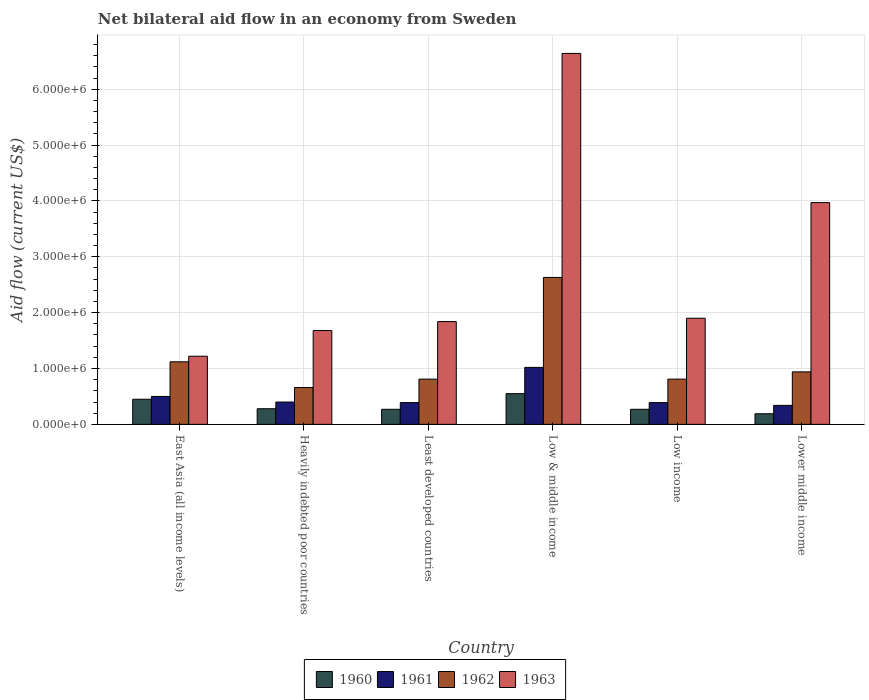How many different coloured bars are there?
Ensure brevity in your answer.  4. How many groups of bars are there?
Your response must be concise. 6. Are the number of bars per tick equal to the number of legend labels?
Make the answer very short. Yes. How many bars are there on the 6th tick from the left?
Keep it short and to the point. 4. How many bars are there on the 6th tick from the right?
Your answer should be very brief. 4. What is the label of the 6th group of bars from the left?
Your answer should be compact. Lower middle income. Across all countries, what is the maximum net bilateral aid flow in 1961?
Make the answer very short. 1.02e+06. In which country was the net bilateral aid flow in 1960 maximum?
Provide a succinct answer. Low & middle income. In which country was the net bilateral aid flow in 1962 minimum?
Offer a very short reply. Heavily indebted poor countries. What is the total net bilateral aid flow in 1960 in the graph?
Your response must be concise. 2.01e+06. What is the difference between the net bilateral aid flow in 1960 in Low & middle income and the net bilateral aid flow in 1963 in Lower middle income?
Your answer should be compact. -3.42e+06. What is the average net bilateral aid flow in 1960 per country?
Offer a very short reply. 3.35e+05. What is the difference between the net bilateral aid flow of/in 1962 and net bilateral aid flow of/in 1960 in Lower middle income?
Provide a short and direct response. 7.50e+05. What is the ratio of the net bilateral aid flow in 1960 in Least developed countries to that in Lower middle income?
Provide a short and direct response. 1.42. Is the net bilateral aid flow in 1962 in Low & middle income less than that in Low income?
Your answer should be compact. No. What is the difference between the highest and the second highest net bilateral aid flow in 1962?
Make the answer very short. 1.51e+06. What is the difference between the highest and the lowest net bilateral aid flow in 1961?
Make the answer very short. 6.80e+05. Is the sum of the net bilateral aid flow in 1962 in Least developed countries and Lower middle income greater than the maximum net bilateral aid flow in 1963 across all countries?
Provide a succinct answer. No. Is it the case that in every country, the sum of the net bilateral aid flow in 1962 and net bilateral aid flow in 1961 is greater than the net bilateral aid flow in 1960?
Keep it short and to the point. Yes. How many bars are there?
Offer a terse response. 24. How many countries are there in the graph?
Keep it short and to the point. 6. What is the difference between two consecutive major ticks on the Y-axis?
Make the answer very short. 1.00e+06. Does the graph contain any zero values?
Your answer should be very brief. No. Where does the legend appear in the graph?
Make the answer very short. Bottom center. How are the legend labels stacked?
Your response must be concise. Horizontal. What is the title of the graph?
Offer a very short reply. Net bilateral aid flow in an economy from Sweden. Does "2009" appear as one of the legend labels in the graph?
Provide a succinct answer. No. What is the Aid flow (current US$) in 1962 in East Asia (all income levels)?
Provide a succinct answer. 1.12e+06. What is the Aid flow (current US$) in 1963 in East Asia (all income levels)?
Provide a succinct answer. 1.22e+06. What is the Aid flow (current US$) in 1960 in Heavily indebted poor countries?
Your answer should be very brief. 2.80e+05. What is the Aid flow (current US$) of 1961 in Heavily indebted poor countries?
Your answer should be very brief. 4.00e+05. What is the Aid flow (current US$) of 1962 in Heavily indebted poor countries?
Make the answer very short. 6.60e+05. What is the Aid flow (current US$) of 1963 in Heavily indebted poor countries?
Your answer should be compact. 1.68e+06. What is the Aid flow (current US$) in 1962 in Least developed countries?
Your response must be concise. 8.10e+05. What is the Aid flow (current US$) in 1963 in Least developed countries?
Your response must be concise. 1.84e+06. What is the Aid flow (current US$) of 1960 in Low & middle income?
Offer a terse response. 5.50e+05. What is the Aid flow (current US$) in 1961 in Low & middle income?
Your answer should be very brief. 1.02e+06. What is the Aid flow (current US$) of 1962 in Low & middle income?
Your response must be concise. 2.63e+06. What is the Aid flow (current US$) of 1963 in Low & middle income?
Your answer should be very brief. 6.64e+06. What is the Aid flow (current US$) of 1960 in Low income?
Your response must be concise. 2.70e+05. What is the Aid flow (current US$) of 1961 in Low income?
Give a very brief answer. 3.90e+05. What is the Aid flow (current US$) in 1962 in Low income?
Make the answer very short. 8.10e+05. What is the Aid flow (current US$) in 1963 in Low income?
Provide a succinct answer. 1.90e+06. What is the Aid flow (current US$) of 1960 in Lower middle income?
Give a very brief answer. 1.90e+05. What is the Aid flow (current US$) of 1961 in Lower middle income?
Offer a very short reply. 3.40e+05. What is the Aid flow (current US$) of 1962 in Lower middle income?
Offer a very short reply. 9.40e+05. What is the Aid flow (current US$) of 1963 in Lower middle income?
Ensure brevity in your answer.  3.97e+06. Across all countries, what is the maximum Aid flow (current US$) in 1960?
Provide a short and direct response. 5.50e+05. Across all countries, what is the maximum Aid flow (current US$) of 1961?
Offer a terse response. 1.02e+06. Across all countries, what is the maximum Aid flow (current US$) in 1962?
Make the answer very short. 2.63e+06. Across all countries, what is the maximum Aid flow (current US$) of 1963?
Offer a very short reply. 6.64e+06. Across all countries, what is the minimum Aid flow (current US$) of 1962?
Offer a terse response. 6.60e+05. Across all countries, what is the minimum Aid flow (current US$) in 1963?
Offer a very short reply. 1.22e+06. What is the total Aid flow (current US$) in 1960 in the graph?
Keep it short and to the point. 2.01e+06. What is the total Aid flow (current US$) of 1961 in the graph?
Your answer should be very brief. 3.04e+06. What is the total Aid flow (current US$) in 1962 in the graph?
Your response must be concise. 6.97e+06. What is the total Aid flow (current US$) of 1963 in the graph?
Offer a very short reply. 1.72e+07. What is the difference between the Aid flow (current US$) of 1963 in East Asia (all income levels) and that in Heavily indebted poor countries?
Ensure brevity in your answer.  -4.60e+05. What is the difference between the Aid flow (current US$) of 1963 in East Asia (all income levels) and that in Least developed countries?
Provide a short and direct response. -6.20e+05. What is the difference between the Aid flow (current US$) of 1961 in East Asia (all income levels) and that in Low & middle income?
Offer a terse response. -5.20e+05. What is the difference between the Aid flow (current US$) in 1962 in East Asia (all income levels) and that in Low & middle income?
Your answer should be compact. -1.51e+06. What is the difference between the Aid flow (current US$) in 1963 in East Asia (all income levels) and that in Low & middle income?
Make the answer very short. -5.42e+06. What is the difference between the Aid flow (current US$) in 1960 in East Asia (all income levels) and that in Low income?
Make the answer very short. 1.80e+05. What is the difference between the Aid flow (current US$) in 1961 in East Asia (all income levels) and that in Low income?
Provide a succinct answer. 1.10e+05. What is the difference between the Aid flow (current US$) in 1962 in East Asia (all income levels) and that in Low income?
Your response must be concise. 3.10e+05. What is the difference between the Aid flow (current US$) of 1963 in East Asia (all income levels) and that in Low income?
Provide a succinct answer. -6.80e+05. What is the difference between the Aid flow (current US$) of 1960 in East Asia (all income levels) and that in Lower middle income?
Make the answer very short. 2.60e+05. What is the difference between the Aid flow (current US$) of 1961 in East Asia (all income levels) and that in Lower middle income?
Make the answer very short. 1.60e+05. What is the difference between the Aid flow (current US$) of 1963 in East Asia (all income levels) and that in Lower middle income?
Keep it short and to the point. -2.75e+06. What is the difference between the Aid flow (current US$) of 1960 in Heavily indebted poor countries and that in Least developed countries?
Your response must be concise. 10000. What is the difference between the Aid flow (current US$) of 1962 in Heavily indebted poor countries and that in Least developed countries?
Your response must be concise. -1.50e+05. What is the difference between the Aid flow (current US$) in 1961 in Heavily indebted poor countries and that in Low & middle income?
Your answer should be very brief. -6.20e+05. What is the difference between the Aid flow (current US$) of 1962 in Heavily indebted poor countries and that in Low & middle income?
Your response must be concise. -1.97e+06. What is the difference between the Aid flow (current US$) in 1963 in Heavily indebted poor countries and that in Low & middle income?
Keep it short and to the point. -4.96e+06. What is the difference between the Aid flow (current US$) in 1960 in Heavily indebted poor countries and that in Low income?
Your answer should be very brief. 10000. What is the difference between the Aid flow (current US$) in 1961 in Heavily indebted poor countries and that in Low income?
Give a very brief answer. 10000. What is the difference between the Aid flow (current US$) of 1960 in Heavily indebted poor countries and that in Lower middle income?
Offer a very short reply. 9.00e+04. What is the difference between the Aid flow (current US$) of 1961 in Heavily indebted poor countries and that in Lower middle income?
Your answer should be compact. 6.00e+04. What is the difference between the Aid flow (current US$) of 1962 in Heavily indebted poor countries and that in Lower middle income?
Keep it short and to the point. -2.80e+05. What is the difference between the Aid flow (current US$) in 1963 in Heavily indebted poor countries and that in Lower middle income?
Offer a terse response. -2.29e+06. What is the difference between the Aid flow (current US$) in 1960 in Least developed countries and that in Low & middle income?
Give a very brief answer. -2.80e+05. What is the difference between the Aid flow (current US$) in 1961 in Least developed countries and that in Low & middle income?
Offer a terse response. -6.30e+05. What is the difference between the Aid flow (current US$) in 1962 in Least developed countries and that in Low & middle income?
Your answer should be very brief. -1.82e+06. What is the difference between the Aid flow (current US$) of 1963 in Least developed countries and that in Low & middle income?
Offer a very short reply. -4.80e+06. What is the difference between the Aid flow (current US$) in 1961 in Least developed countries and that in Low income?
Your response must be concise. 0. What is the difference between the Aid flow (current US$) in 1962 in Least developed countries and that in Low income?
Provide a succinct answer. 0. What is the difference between the Aid flow (current US$) in 1963 in Least developed countries and that in Low income?
Make the answer very short. -6.00e+04. What is the difference between the Aid flow (current US$) in 1963 in Least developed countries and that in Lower middle income?
Offer a very short reply. -2.13e+06. What is the difference between the Aid flow (current US$) of 1961 in Low & middle income and that in Low income?
Provide a succinct answer. 6.30e+05. What is the difference between the Aid flow (current US$) in 1962 in Low & middle income and that in Low income?
Keep it short and to the point. 1.82e+06. What is the difference between the Aid flow (current US$) in 1963 in Low & middle income and that in Low income?
Provide a succinct answer. 4.74e+06. What is the difference between the Aid flow (current US$) of 1960 in Low & middle income and that in Lower middle income?
Provide a succinct answer. 3.60e+05. What is the difference between the Aid flow (current US$) in 1961 in Low & middle income and that in Lower middle income?
Provide a succinct answer. 6.80e+05. What is the difference between the Aid flow (current US$) of 1962 in Low & middle income and that in Lower middle income?
Offer a terse response. 1.69e+06. What is the difference between the Aid flow (current US$) in 1963 in Low & middle income and that in Lower middle income?
Offer a terse response. 2.67e+06. What is the difference between the Aid flow (current US$) of 1962 in Low income and that in Lower middle income?
Keep it short and to the point. -1.30e+05. What is the difference between the Aid flow (current US$) in 1963 in Low income and that in Lower middle income?
Give a very brief answer. -2.07e+06. What is the difference between the Aid flow (current US$) in 1960 in East Asia (all income levels) and the Aid flow (current US$) in 1961 in Heavily indebted poor countries?
Offer a very short reply. 5.00e+04. What is the difference between the Aid flow (current US$) in 1960 in East Asia (all income levels) and the Aid flow (current US$) in 1963 in Heavily indebted poor countries?
Your answer should be compact. -1.23e+06. What is the difference between the Aid flow (current US$) in 1961 in East Asia (all income levels) and the Aid flow (current US$) in 1963 in Heavily indebted poor countries?
Keep it short and to the point. -1.18e+06. What is the difference between the Aid flow (current US$) in 1962 in East Asia (all income levels) and the Aid flow (current US$) in 1963 in Heavily indebted poor countries?
Provide a short and direct response. -5.60e+05. What is the difference between the Aid flow (current US$) of 1960 in East Asia (all income levels) and the Aid flow (current US$) of 1962 in Least developed countries?
Offer a terse response. -3.60e+05. What is the difference between the Aid flow (current US$) of 1960 in East Asia (all income levels) and the Aid flow (current US$) of 1963 in Least developed countries?
Provide a short and direct response. -1.39e+06. What is the difference between the Aid flow (current US$) of 1961 in East Asia (all income levels) and the Aid flow (current US$) of 1962 in Least developed countries?
Offer a terse response. -3.10e+05. What is the difference between the Aid flow (current US$) of 1961 in East Asia (all income levels) and the Aid flow (current US$) of 1963 in Least developed countries?
Your answer should be compact. -1.34e+06. What is the difference between the Aid flow (current US$) of 1962 in East Asia (all income levels) and the Aid flow (current US$) of 1963 in Least developed countries?
Keep it short and to the point. -7.20e+05. What is the difference between the Aid flow (current US$) in 1960 in East Asia (all income levels) and the Aid flow (current US$) in 1961 in Low & middle income?
Your response must be concise. -5.70e+05. What is the difference between the Aid flow (current US$) in 1960 in East Asia (all income levels) and the Aid flow (current US$) in 1962 in Low & middle income?
Give a very brief answer. -2.18e+06. What is the difference between the Aid flow (current US$) of 1960 in East Asia (all income levels) and the Aid flow (current US$) of 1963 in Low & middle income?
Offer a very short reply. -6.19e+06. What is the difference between the Aid flow (current US$) of 1961 in East Asia (all income levels) and the Aid flow (current US$) of 1962 in Low & middle income?
Offer a terse response. -2.13e+06. What is the difference between the Aid flow (current US$) of 1961 in East Asia (all income levels) and the Aid flow (current US$) of 1963 in Low & middle income?
Provide a short and direct response. -6.14e+06. What is the difference between the Aid flow (current US$) in 1962 in East Asia (all income levels) and the Aid flow (current US$) in 1963 in Low & middle income?
Offer a very short reply. -5.52e+06. What is the difference between the Aid flow (current US$) of 1960 in East Asia (all income levels) and the Aid flow (current US$) of 1961 in Low income?
Offer a very short reply. 6.00e+04. What is the difference between the Aid flow (current US$) of 1960 in East Asia (all income levels) and the Aid flow (current US$) of 1962 in Low income?
Provide a short and direct response. -3.60e+05. What is the difference between the Aid flow (current US$) in 1960 in East Asia (all income levels) and the Aid flow (current US$) in 1963 in Low income?
Your answer should be very brief. -1.45e+06. What is the difference between the Aid flow (current US$) of 1961 in East Asia (all income levels) and the Aid flow (current US$) of 1962 in Low income?
Offer a very short reply. -3.10e+05. What is the difference between the Aid flow (current US$) of 1961 in East Asia (all income levels) and the Aid flow (current US$) of 1963 in Low income?
Make the answer very short. -1.40e+06. What is the difference between the Aid flow (current US$) in 1962 in East Asia (all income levels) and the Aid flow (current US$) in 1963 in Low income?
Make the answer very short. -7.80e+05. What is the difference between the Aid flow (current US$) in 1960 in East Asia (all income levels) and the Aid flow (current US$) in 1961 in Lower middle income?
Your answer should be very brief. 1.10e+05. What is the difference between the Aid flow (current US$) in 1960 in East Asia (all income levels) and the Aid flow (current US$) in 1962 in Lower middle income?
Offer a terse response. -4.90e+05. What is the difference between the Aid flow (current US$) of 1960 in East Asia (all income levels) and the Aid flow (current US$) of 1963 in Lower middle income?
Provide a short and direct response. -3.52e+06. What is the difference between the Aid flow (current US$) in 1961 in East Asia (all income levels) and the Aid flow (current US$) in 1962 in Lower middle income?
Your response must be concise. -4.40e+05. What is the difference between the Aid flow (current US$) in 1961 in East Asia (all income levels) and the Aid flow (current US$) in 1963 in Lower middle income?
Your answer should be very brief. -3.47e+06. What is the difference between the Aid flow (current US$) in 1962 in East Asia (all income levels) and the Aid flow (current US$) in 1963 in Lower middle income?
Your answer should be compact. -2.85e+06. What is the difference between the Aid flow (current US$) of 1960 in Heavily indebted poor countries and the Aid flow (current US$) of 1961 in Least developed countries?
Your answer should be very brief. -1.10e+05. What is the difference between the Aid flow (current US$) in 1960 in Heavily indebted poor countries and the Aid flow (current US$) in 1962 in Least developed countries?
Make the answer very short. -5.30e+05. What is the difference between the Aid flow (current US$) in 1960 in Heavily indebted poor countries and the Aid flow (current US$) in 1963 in Least developed countries?
Your answer should be very brief. -1.56e+06. What is the difference between the Aid flow (current US$) of 1961 in Heavily indebted poor countries and the Aid flow (current US$) of 1962 in Least developed countries?
Your answer should be very brief. -4.10e+05. What is the difference between the Aid flow (current US$) of 1961 in Heavily indebted poor countries and the Aid flow (current US$) of 1963 in Least developed countries?
Give a very brief answer. -1.44e+06. What is the difference between the Aid flow (current US$) of 1962 in Heavily indebted poor countries and the Aid flow (current US$) of 1963 in Least developed countries?
Give a very brief answer. -1.18e+06. What is the difference between the Aid flow (current US$) in 1960 in Heavily indebted poor countries and the Aid flow (current US$) in 1961 in Low & middle income?
Your response must be concise. -7.40e+05. What is the difference between the Aid flow (current US$) in 1960 in Heavily indebted poor countries and the Aid flow (current US$) in 1962 in Low & middle income?
Give a very brief answer. -2.35e+06. What is the difference between the Aid flow (current US$) of 1960 in Heavily indebted poor countries and the Aid flow (current US$) of 1963 in Low & middle income?
Make the answer very short. -6.36e+06. What is the difference between the Aid flow (current US$) in 1961 in Heavily indebted poor countries and the Aid flow (current US$) in 1962 in Low & middle income?
Give a very brief answer. -2.23e+06. What is the difference between the Aid flow (current US$) of 1961 in Heavily indebted poor countries and the Aid flow (current US$) of 1963 in Low & middle income?
Your response must be concise. -6.24e+06. What is the difference between the Aid flow (current US$) in 1962 in Heavily indebted poor countries and the Aid flow (current US$) in 1963 in Low & middle income?
Make the answer very short. -5.98e+06. What is the difference between the Aid flow (current US$) in 1960 in Heavily indebted poor countries and the Aid flow (current US$) in 1961 in Low income?
Provide a short and direct response. -1.10e+05. What is the difference between the Aid flow (current US$) in 1960 in Heavily indebted poor countries and the Aid flow (current US$) in 1962 in Low income?
Your answer should be very brief. -5.30e+05. What is the difference between the Aid flow (current US$) of 1960 in Heavily indebted poor countries and the Aid flow (current US$) of 1963 in Low income?
Make the answer very short. -1.62e+06. What is the difference between the Aid flow (current US$) in 1961 in Heavily indebted poor countries and the Aid flow (current US$) in 1962 in Low income?
Make the answer very short. -4.10e+05. What is the difference between the Aid flow (current US$) of 1961 in Heavily indebted poor countries and the Aid flow (current US$) of 1963 in Low income?
Your answer should be very brief. -1.50e+06. What is the difference between the Aid flow (current US$) of 1962 in Heavily indebted poor countries and the Aid flow (current US$) of 1963 in Low income?
Your answer should be very brief. -1.24e+06. What is the difference between the Aid flow (current US$) of 1960 in Heavily indebted poor countries and the Aid flow (current US$) of 1962 in Lower middle income?
Ensure brevity in your answer.  -6.60e+05. What is the difference between the Aid flow (current US$) of 1960 in Heavily indebted poor countries and the Aid flow (current US$) of 1963 in Lower middle income?
Ensure brevity in your answer.  -3.69e+06. What is the difference between the Aid flow (current US$) of 1961 in Heavily indebted poor countries and the Aid flow (current US$) of 1962 in Lower middle income?
Provide a succinct answer. -5.40e+05. What is the difference between the Aid flow (current US$) in 1961 in Heavily indebted poor countries and the Aid flow (current US$) in 1963 in Lower middle income?
Your response must be concise. -3.57e+06. What is the difference between the Aid flow (current US$) in 1962 in Heavily indebted poor countries and the Aid flow (current US$) in 1963 in Lower middle income?
Offer a terse response. -3.31e+06. What is the difference between the Aid flow (current US$) of 1960 in Least developed countries and the Aid flow (current US$) of 1961 in Low & middle income?
Your answer should be very brief. -7.50e+05. What is the difference between the Aid flow (current US$) in 1960 in Least developed countries and the Aid flow (current US$) in 1962 in Low & middle income?
Offer a very short reply. -2.36e+06. What is the difference between the Aid flow (current US$) in 1960 in Least developed countries and the Aid flow (current US$) in 1963 in Low & middle income?
Offer a very short reply. -6.37e+06. What is the difference between the Aid flow (current US$) in 1961 in Least developed countries and the Aid flow (current US$) in 1962 in Low & middle income?
Offer a terse response. -2.24e+06. What is the difference between the Aid flow (current US$) in 1961 in Least developed countries and the Aid flow (current US$) in 1963 in Low & middle income?
Provide a succinct answer. -6.25e+06. What is the difference between the Aid flow (current US$) in 1962 in Least developed countries and the Aid flow (current US$) in 1963 in Low & middle income?
Your answer should be compact. -5.83e+06. What is the difference between the Aid flow (current US$) of 1960 in Least developed countries and the Aid flow (current US$) of 1962 in Low income?
Offer a terse response. -5.40e+05. What is the difference between the Aid flow (current US$) of 1960 in Least developed countries and the Aid flow (current US$) of 1963 in Low income?
Offer a very short reply. -1.63e+06. What is the difference between the Aid flow (current US$) of 1961 in Least developed countries and the Aid flow (current US$) of 1962 in Low income?
Your response must be concise. -4.20e+05. What is the difference between the Aid flow (current US$) in 1961 in Least developed countries and the Aid flow (current US$) in 1963 in Low income?
Offer a very short reply. -1.51e+06. What is the difference between the Aid flow (current US$) of 1962 in Least developed countries and the Aid flow (current US$) of 1963 in Low income?
Provide a short and direct response. -1.09e+06. What is the difference between the Aid flow (current US$) of 1960 in Least developed countries and the Aid flow (current US$) of 1961 in Lower middle income?
Provide a short and direct response. -7.00e+04. What is the difference between the Aid flow (current US$) of 1960 in Least developed countries and the Aid flow (current US$) of 1962 in Lower middle income?
Offer a terse response. -6.70e+05. What is the difference between the Aid flow (current US$) of 1960 in Least developed countries and the Aid flow (current US$) of 1963 in Lower middle income?
Your answer should be very brief. -3.70e+06. What is the difference between the Aid flow (current US$) of 1961 in Least developed countries and the Aid flow (current US$) of 1962 in Lower middle income?
Keep it short and to the point. -5.50e+05. What is the difference between the Aid flow (current US$) of 1961 in Least developed countries and the Aid flow (current US$) of 1963 in Lower middle income?
Your answer should be compact. -3.58e+06. What is the difference between the Aid flow (current US$) of 1962 in Least developed countries and the Aid flow (current US$) of 1963 in Lower middle income?
Provide a succinct answer. -3.16e+06. What is the difference between the Aid flow (current US$) in 1960 in Low & middle income and the Aid flow (current US$) in 1961 in Low income?
Ensure brevity in your answer.  1.60e+05. What is the difference between the Aid flow (current US$) of 1960 in Low & middle income and the Aid flow (current US$) of 1963 in Low income?
Provide a succinct answer. -1.35e+06. What is the difference between the Aid flow (current US$) of 1961 in Low & middle income and the Aid flow (current US$) of 1963 in Low income?
Offer a very short reply. -8.80e+05. What is the difference between the Aid flow (current US$) of 1962 in Low & middle income and the Aid flow (current US$) of 1963 in Low income?
Your answer should be compact. 7.30e+05. What is the difference between the Aid flow (current US$) of 1960 in Low & middle income and the Aid flow (current US$) of 1962 in Lower middle income?
Offer a very short reply. -3.90e+05. What is the difference between the Aid flow (current US$) in 1960 in Low & middle income and the Aid flow (current US$) in 1963 in Lower middle income?
Provide a succinct answer. -3.42e+06. What is the difference between the Aid flow (current US$) in 1961 in Low & middle income and the Aid flow (current US$) in 1963 in Lower middle income?
Offer a terse response. -2.95e+06. What is the difference between the Aid flow (current US$) in 1962 in Low & middle income and the Aid flow (current US$) in 1963 in Lower middle income?
Your answer should be very brief. -1.34e+06. What is the difference between the Aid flow (current US$) of 1960 in Low income and the Aid flow (current US$) of 1961 in Lower middle income?
Your response must be concise. -7.00e+04. What is the difference between the Aid flow (current US$) in 1960 in Low income and the Aid flow (current US$) in 1962 in Lower middle income?
Your answer should be very brief. -6.70e+05. What is the difference between the Aid flow (current US$) in 1960 in Low income and the Aid flow (current US$) in 1963 in Lower middle income?
Offer a very short reply. -3.70e+06. What is the difference between the Aid flow (current US$) in 1961 in Low income and the Aid flow (current US$) in 1962 in Lower middle income?
Offer a very short reply. -5.50e+05. What is the difference between the Aid flow (current US$) in 1961 in Low income and the Aid flow (current US$) in 1963 in Lower middle income?
Give a very brief answer. -3.58e+06. What is the difference between the Aid flow (current US$) in 1962 in Low income and the Aid flow (current US$) in 1963 in Lower middle income?
Your answer should be very brief. -3.16e+06. What is the average Aid flow (current US$) of 1960 per country?
Make the answer very short. 3.35e+05. What is the average Aid flow (current US$) of 1961 per country?
Keep it short and to the point. 5.07e+05. What is the average Aid flow (current US$) of 1962 per country?
Offer a very short reply. 1.16e+06. What is the average Aid flow (current US$) in 1963 per country?
Provide a succinct answer. 2.88e+06. What is the difference between the Aid flow (current US$) of 1960 and Aid flow (current US$) of 1961 in East Asia (all income levels)?
Make the answer very short. -5.00e+04. What is the difference between the Aid flow (current US$) in 1960 and Aid flow (current US$) in 1962 in East Asia (all income levels)?
Make the answer very short. -6.70e+05. What is the difference between the Aid flow (current US$) of 1960 and Aid flow (current US$) of 1963 in East Asia (all income levels)?
Provide a short and direct response. -7.70e+05. What is the difference between the Aid flow (current US$) in 1961 and Aid flow (current US$) in 1962 in East Asia (all income levels)?
Give a very brief answer. -6.20e+05. What is the difference between the Aid flow (current US$) in 1961 and Aid flow (current US$) in 1963 in East Asia (all income levels)?
Provide a succinct answer. -7.20e+05. What is the difference between the Aid flow (current US$) of 1962 and Aid flow (current US$) of 1963 in East Asia (all income levels)?
Give a very brief answer. -1.00e+05. What is the difference between the Aid flow (current US$) of 1960 and Aid flow (current US$) of 1961 in Heavily indebted poor countries?
Provide a succinct answer. -1.20e+05. What is the difference between the Aid flow (current US$) in 1960 and Aid flow (current US$) in 1962 in Heavily indebted poor countries?
Make the answer very short. -3.80e+05. What is the difference between the Aid flow (current US$) in 1960 and Aid flow (current US$) in 1963 in Heavily indebted poor countries?
Give a very brief answer. -1.40e+06. What is the difference between the Aid flow (current US$) in 1961 and Aid flow (current US$) in 1962 in Heavily indebted poor countries?
Ensure brevity in your answer.  -2.60e+05. What is the difference between the Aid flow (current US$) of 1961 and Aid flow (current US$) of 1963 in Heavily indebted poor countries?
Offer a terse response. -1.28e+06. What is the difference between the Aid flow (current US$) of 1962 and Aid flow (current US$) of 1963 in Heavily indebted poor countries?
Provide a short and direct response. -1.02e+06. What is the difference between the Aid flow (current US$) in 1960 and Aid flow (current US$) in 1962 in Least developed countries?
Give a very brief answer. -5.40e+05. What is the difference between the Aid flow (current US$) of 1960 and Aid flow (current US$) of 1963 in Least developed countries?
Make the answer very short. -1.57e+06. What is the difference between the Aid flow (current US$) in 1961 and Aid flow (current US$) in 1962 in Least developed countries?
Offer a terse response. -4.20e+05. What is the difference between the Aid flow (current US$) in 1961 and Aid flow (current US$) in 1963 in Least developed countries?
Make the answer very short. -1.45e+06. What is the difference between the Aid flow (current US$) of 1962 and Aid flow (current US$) of 1963 in Least developed countries?
Give a very brief answer. -1.03e+06. What is the difference between the Aid flow (current US$) of 1960 and Aid flow (current US$) of 1961 in Low & middle income?
Offer a terse response. -4.70e+05. What is the difference between the Aid flow (current US$) of 1960 and Aid flow (current US$) of 1962 in Low & middle income?
Provide a short and direct response. -2.08e+06. What is the difference between the Aid flow (current US$) of 1960 and Aid flow (current US$) of 1963 in Low & middle income?
Keep it short and to the point. -6.09e+06. What is the difference between the Aid flow (current US$) of 1961 and Aid flow (current US$) of 1962 in Low & middle income?
Your answer should be very brief. -1.61e+06. What is the difference between the Aid flow (current US$) of 1961 and Aid flow (current US$) of 1963 in Low & middle income?
Your answer should be very brief. -5.62e+06. What is the difference between the Aid flow (current US$) in 1962 and Aid flow (current US$) in 1963 in Low & middle income?
Your answer should be compact. -4.01e+06. What is the difference between the Aid flow (current US$) in 1960 and Aid flow (current US$) in 1961 in Low income?
Your answer should be very brief. -1.20e+05. What is the difference between the Aid flow (current US$) of 1960 and Aid flow (current US$) of 1962 in Low income?
Offer a terse response. -5.40e+05. What is the difference between the Aid flow (current US$) in 1960 and Aid flow (current US$) in 1963 in Low income?
Your answer should be compact. -1.63e+06. What is the difference between the Aid flow (current US$) in 1961 and Aid flow (current US$) in 1962 in Low income?
Provide a short and direct response. -4.20e+05. What is the difference between the Aid flow (current US$) of 1961 and Aid flow (current US$) of 1963 in Low income?
Give a very brief answer. -1.51e+06. What is the difference between the Aid flow (current US$) in 1962 and Aid flow (current US$) in 1963 in Low income?
Your response must be concise. -1.09e+06. What is the difference between the Aid flow (current US$) in 1960 and Aid flow (current US$) in 1962 in Lower middle income?
Keep it short and to the point. -7.50e+05. What is the difference between the Aid flow (current US$) of 1960 and Aid flow (current US$) of 1963 in Lower middle income?
Provide a succinct answer. -3.78e+06. What is the difference between the Aid flow (current US$) in 1961 and Aid flow (current US$) in 1962 in Lower middle income?
Your answer should be very brief. -6.00e+05. What is the difference between the Aid flow (current US$) in 1961 and Aid flow (current US$) in 1963 in Lower middle income?
Provide a short and direct response. -3.63e+06. What is the difference between the Aid flow (current US$) of 1962 and Aid flow (current US$) of 1963 in Lower middle income?
Your answer should be compact. -3.03e+06. What is the ratio of the Aid flow (current US$) in 1960 in East Asia (all income levels) to that in Heavily indebted poor countries?
Provide a short and direct response. 1.61. What is the ratio of the Aid flow (current US$) of 1961 in East Asia (all income levels) to that in Heavily indebted poor countries?
Your response must be concise. 1.25. What is the ratio of the Aid flow (current US$) of 1962 in East Asia (all income levels) to that in Heavily indebted poor countries?
Your response must be concise. 1.7. What is the ratio of the Aid flow (current US$) in 1963 in East Asia (all income levels) to that in Heavily indebted poor countries?
Give a very brief answer. 0.73. What is the ratio of the Aid flow (current US$) in 1960 in East Asia (all income levels) to that in Least developed countries?
Offer a terse response. 1.67. What is the ratio of the Aid flow (current US$) of 1961 in East Asia (all income levels) to that in Least developed countries?
Provide a succinct answer. 1.28. What is the ratio of the Aid flow (current US$) in 1962 in East Asia (all income levels) to that in Least developed countries?
Your answer should be very brief. 1.38. What is the ratio of the Aid flow (current US$) of 1963 in East Asia (all income levels) to that in Least developed countries?
Provide a succinct answer. 0.66. What is the ratio of the Aid flow (current US$) of 1960 in East Asia (all income levels) to that in Low & middle income?
Keep it short and to the point. 0.82. What is the ratio of the Aid flow (current US$) of 1961 in East Asia (all income levels) to that in Low & middle income?
Your answer should be very brief. 0.49. What is the ratio of the Aid flow (current US$) of 1962 in East Asia (all income levels) to that in Low & middle income?
Offer a very short reply. 0.43. What is the ratio of the Aid flow (current US$) in 1963 in East Asia (all income levels) to that in Low & middle income?
Keep it short and to the point. 0.18. What is the ratio of the Aid flow (current US$) in 1961 in East Asia (all income levels) to that in Low income?
Your answer should be very brief. 1.28. What is the ratio of the Aid flow (current US$) of 1962 in East Asia (all income levels) to that in Low income?
Offer a terse response. 1.38. What is the ratio of the Aid flow (current US$) of 1963 in East Asia (all income levels) to that in Low income?
Offer a very short reply. 0.64. What is the ratio of the Aid flow (current US$) in 1960 in East Asia (all income levels) to that in Lower middle income?
Offer a very short reply. 2.37. What is the ratio of the Aid flow (current US$) in 1961 in East Asia (all income levels) to that in Lower middle income?
Your answer should be very brief. 1.47. What is the ratio of the Aid flow (current US$) in 1962 in East Asia (all income levels) to that in Lower middle income?
Your answer should be compact. 1.19. What is the ratio of the Aid flow (current US$) of 1963 in East Asia (all income levels) to that in Lower middle income?
Make the answer very short. 0.31. What is the ratio of the Aid flow (current US$) of 1960 in Heavily indebted poor countries to that in Least developed countries?
Offer a very short reply. 1.04. What is the ratio of the Aid flow (current US$) of 1961 in Heavily indebted poor countries to that in Least developed countries?
Ensure brevity in your answer.  1.03. What is the ratio of the Aid flow (current US$) of 1962 in Heavily indebted poor countries to that in Least developed countries?
Offer a very short reply. 0.81. What is the ratio of the Aid flow (current US$) in 1963 in Heavily indebted poor countries to that in Least developed countries?
Offer a terse response. 0.91. What is the ratio of the Aid flow (current US$) in 1960 in Heavily indebted poor countries to that in Low & middle income?
Offer a very short reply. 0.51. What is the ratio of the Aid flow (current US$) of 1961 in Heavily indebted poor countries to that in Low & middle income?
Provide a succinct answer. 0.39. What is the ratio of the Aid flow (current US$) in 1962 in Heavily indebted poor countries to that in Low & middle income?
Keep it short and to the point. 0.25. What is the ratio of the Aid flow (current US$) of 1963 in Heavily indebted poor countries to that in Low & middle income?
Your answer should be very brief. 0.25. What is the ratio of the Aid flow (current US$) in 1961 in Heavily indebted poor countries to that in Low income?
Offer a very short reply. 1.03. What is the ratio of the Aid flow (current US$) in 1962 in Heavily indebted poor countries to that in Low income?
Your answer should be very brief. 0.81. What is the ratio of the Aid flow (current US$) of 1963 in Heavily indebted poor countries to that in Low income?
Provide a short and direct response. 0.88. What is the ratio of the Aid flow (current US$) of 1960 in Heavily indebted poor countries to that in Lower middle income?
Your answer should be compact. 1.47. What is the ratio of the Aid flow (current US$) of 1961 in Heavily indebted poor countries to that in Lower middle income?
Your response must be concise. 1.18. What is the ratio of the Aid flow (current US$) in 1962 in Heavily indebted poor countries to that in Lower middle income?
Offer a very short reply. 0.7. What is the ratio of the Aid flow (current US$) of 1963 in Heavily indebted poor countries to that in Lower middle income?
Your response must be concise. 0.42. What is the ratio of the Aid flow (current US$) in 1960 in Least developed countries to that in Low & middle income?
Provide a succinct answer. 0.49. What is the ratio of the Aid flow (current US$) of 1961 in Least developed countries to that in Low & middle income?
Your response must be concise. 0.38. What is the ratio of the Aid flow (current US$) of 1962 in Least developed countries to that in Low & middle income?
Make the answer very short. 0.31. What is the ratio of the Aid flow (current US$) in 1963 in Least developed countries to that in Low & middle income?
Make the answer very short. 0.28. What is the ratio of the Aid flow (current US$) in 1962 in Least developed countries to that in Low income?
Offer a very short reply. 1. What is the ratio of the Aid flow (current US$) in 1963 in Least developed countries to that in Low income?
Offer a very short reply. 0.97. What is the ratio of the Aid flow (current US$) in 1960 in Least developed countries to that in Lower middle income?
Your answer should be compact. 1.42. What is the ratio of the Aid flow (current US$) in 1961 in Least developed countries to that in Lower middle income?
Offer a very short reply. 1.15. What is the ratio of the Aid flow (current US$) of 1962 in Least developed countries to that in Lower middle income?
Your response must be concise. 0.86. What is the ratio of the Aid flow (current US$) of 1963 in Least developed countries to that in Lower middle income?
Provide a short and direct response. 0.46. What is the ratio of the Aid flow (current US$) in 1960 in Low & middle income to that in Low income?
Your response must be concise. 2.04. What is the ratio of the Aid flow (current US$) in 1961 in Low & middle income to that in Low income?
Keep it short and to the point. 2.62. What is the ratio of the Aid flow (current US$) of 1962 in Low & middle income to that in Low income?
Keep it short and to the point. 3.25. What is the ratio of the Aid flow (current US$) of 1963 in Low & middle income to that in Low income?
Give a very brief answer. 3.49. What is the ratio of the Aid flow (current US$) in 1960 in Low & middle income to that in Lower middle income?
Keep it short and to the point. 2.89. What is the ratio of the Aid flow (current US$) in 1962 in Low & middle income to that in Lower middle income?
Your answer should be compact. 2.8. What is the ratio of the Aid flow (current US$) of 1963 in Low & middle income to that in Lower middle income?
Provide a succinct answer. 1.67. What is the ratio of the Aid flow (current US$) in 1960 in Low income to that in Lower middle income?
Make the answer very short. 1.42. What is the ratio of the Aid flow (current US$) of 1961 in Low income to that in Lower middle income?
Provide a succinct answer. 1.15. What is the ratio of the Aid flow (current US$) in 1962 in Low income to that in Lower middle income?
Offer a very short reply. 0.86. What is the ratio of the Aid flow (current US$) of 1963 in Low income to that in Lower middle income?
Make the answer very short. 0.48. What is the difference between the highest and the second highest Aid flow (current US$) of 1961?
Your answer should be compact. 5.20e+05. What is the difference between the highest and the second highest Aid flow (current US$) of 1962?
Provide a short and direct response. 1.51e+06. What is the difference between the highest and the second highest Aid flow (current US$) of 1963?
Make the answer very short. 2.67e+06. What is the difference between the highest and the lowest Aid flow (current US$) in 1960?
Your answer should be compact. 3.60e+05. What is the difference between the highest and the lowest Aid flow (current US$) in 1961?
Offer a very short reply. 6.80e+05. What is the difference between the highest and the lowest Aid flow (current US$) in 1962?
Make the answer very short. 1.97e+06. What is the difference between the highest and the lowest Aid flow (current US$) in 1963?
Provide a succinct answer. 5.42e+06. 